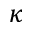Convert formula to latex. <formula><loc_0><loc_0><loc_500><loc_500>\kappa</formula> 